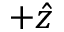<formula> <loc_0><loc_0><loc_500><loc_500>+ \hat { z }</formula> 